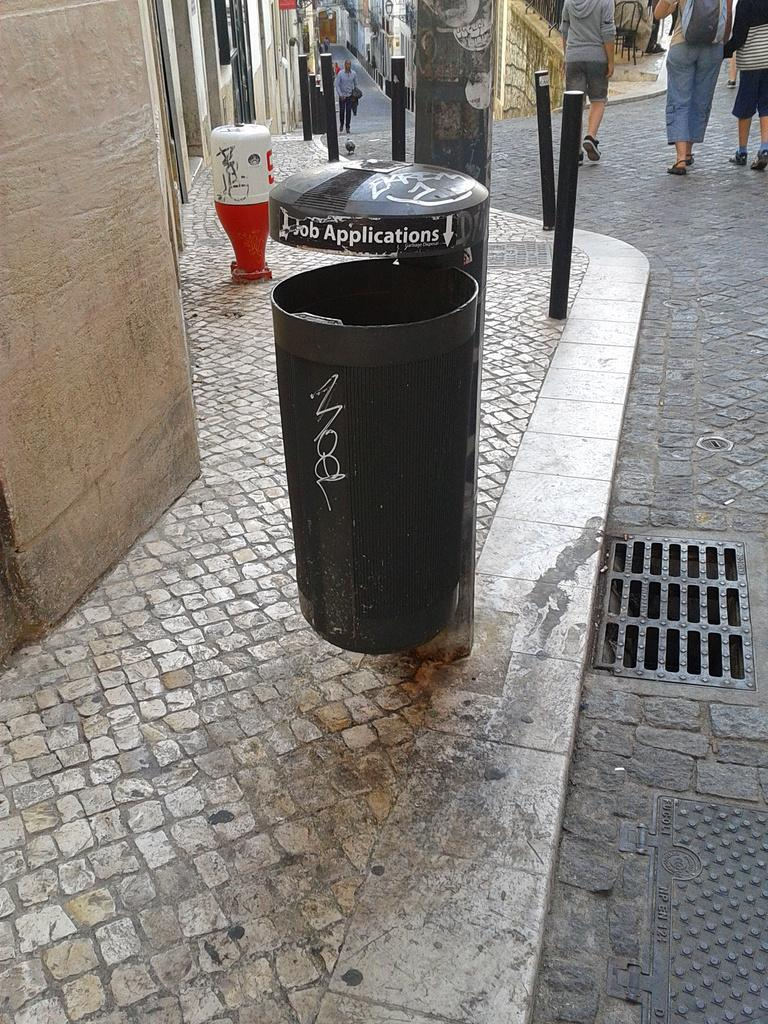Provide a one-sentence caption for the provided image. A BLACK SIDEWALK TRASHCAN WITH A JOB APPLICATION BUMMER STICKER. 